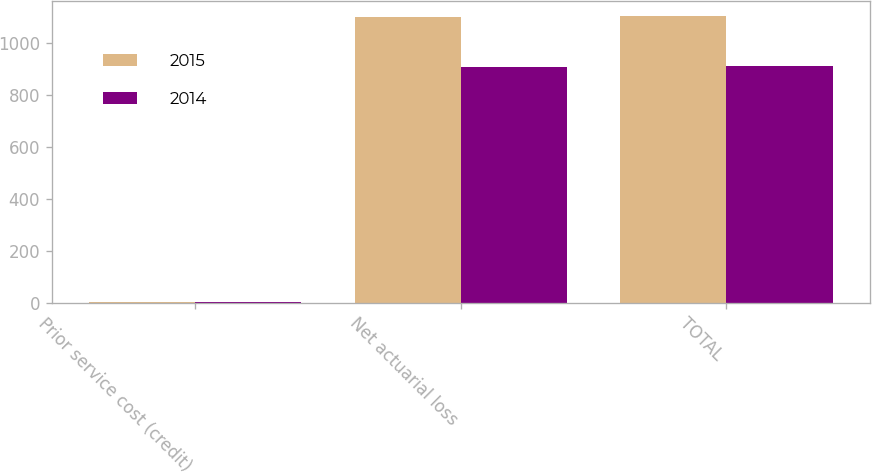Convert chart. <chart><loc_0><loc_0><loc_500><loc_500><stacked_bar_chart><ecel><fcel>Prior service cost (credit)<fcel>Net actuarial loss<fcel>TOTAL<nl><fcel>2015<fcel>3<fcel>1099.9<fcel>1102.9<nl><fcel>2014<fcel>4<fcel>904.7<fcel>908.7<nl></chart> 